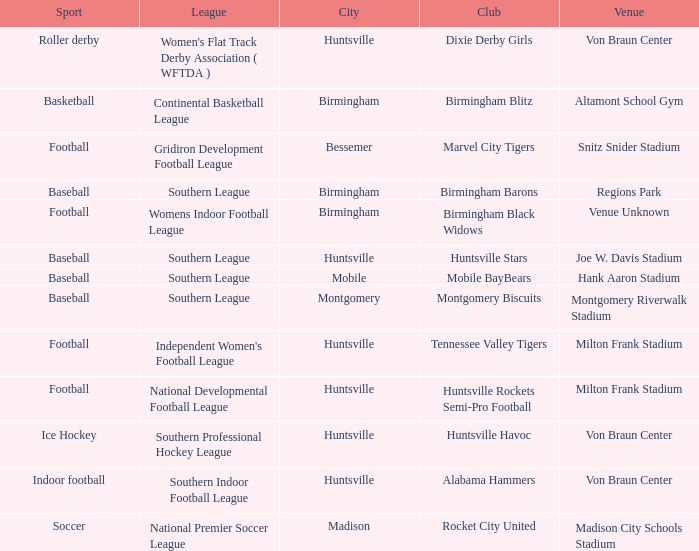Which venue hosted the Gridiron Development Football League? Snitz Snider Stadium. 